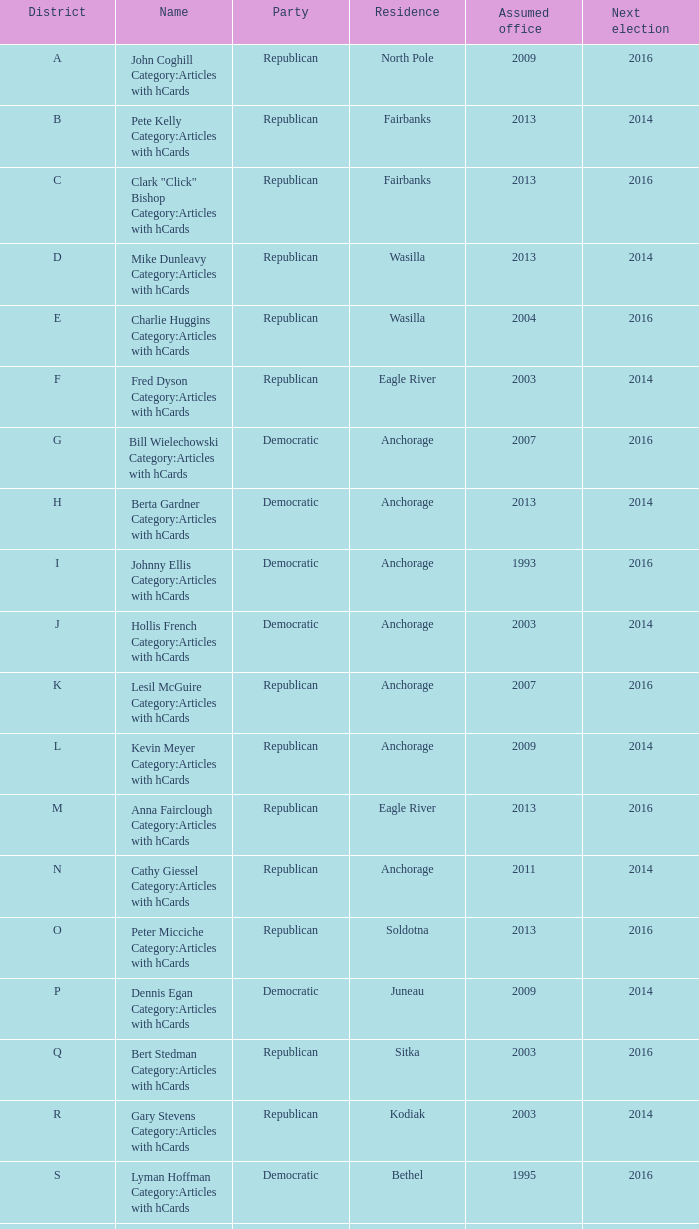What is the title of the o district senator who took office in 2013? Peter Micciche Category:Articles with hCards. 